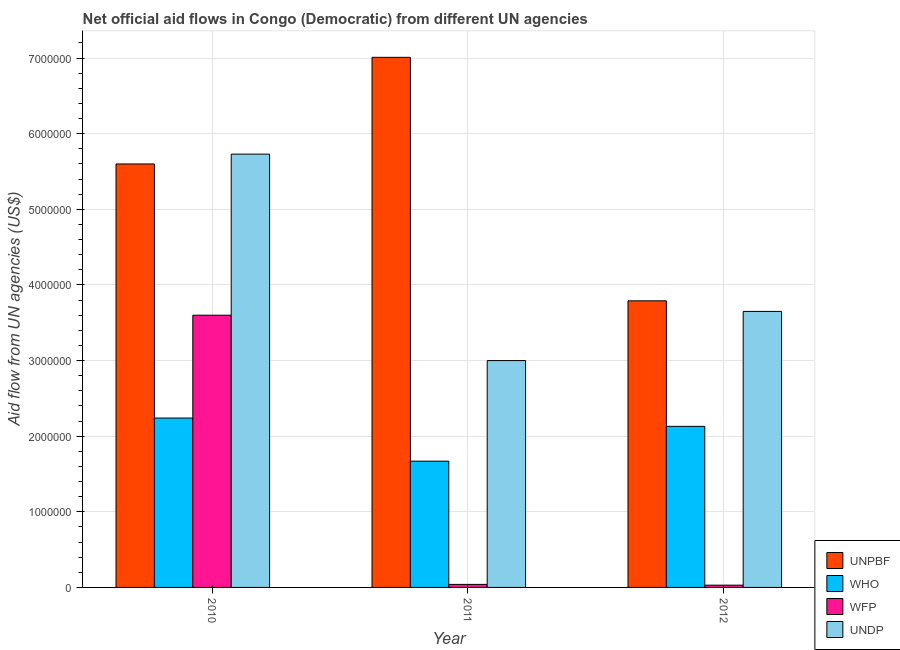How many different coloured bars are there?
Ensure brevity in your answer.  4. How many groups of bars are there?
Your response must be concise. 3. Are the number of bars per tick equal to the number of legend labels?
Keep it short and to the point. Yes. Are the number of bars on each tick of the X-axis equal?
Give a very brief answer. Yes. How many bars are there on the 2nd tick from the right?
Make the answer very short. 4. In how many cases, is the number of bars for a given year not equal to the number of legend labels?
Provide a succinct answer. 0. What is the amount of aid given by undp in 2011?
Ensure brevity in your answer.  3.00e+06. Across all years, what is the maximum amount of aid given by who?
Provide a succinct answer. 2.24e+06. Across all years, what is the minimum amount of aid given by undp?
Provide a succinct answer. 3.00e+06. In which year was the amount of aid given by who maximum?
Your answer should be compact. 2010. What is the total amount of aid given by wfp in the graph?
Give a very brief answer. 3.67e+06. What is the difference between the amount of aid given by unpbf in 2010 and that in 2012?
Give a very brief answer. 1.81e+06. What is the difference between the amount of aid given by unpbf in 2010 and the amount of aid given by wfp in 2011?
Provide a succinct answer. -1.41e+06. What is the average amount of aid given by unpbf per year?
Give a very brief answer. 5.47e+06. In the year 2012, what is the difference between the amount of aid given by who and amount of aid given by unpbf?
Your answer should be compact. 0. What is the ratio of the amount of aid given by unpbf in 2010 to that in 2012?
Your answer should be very brief. 1.48. Is the amount of aid given by who in 2010 less than that in 2011?
Offer a terse response. No. Is the difference between the amount of aid given by undp in 2010 and 2011 greater than the difference between the amount of aid given by who in 2010 and 2011?
Offer a terse response. No. What is the difference between the highest and the second highest amount of aid given by undp?
Make the answer very short. 2.08e+06. What is the difference between the highest and the lowest amount of aid given by undp?
Your response must be concise. 2.73e+06. Is it the case that in every year, the sum of the amount of aid given by undp and amount of aid given by who is greater than the sum of amount of aid given by wfp and amount of aid given by unpbf?
Offer a very short reply. No. What does the 1st bar from the left in 2012 represents?
Provide a succinct answer. UNPBF. What does the 3rd bar from the right in 2011 represents?
Give a very brief answer. WHO. How many bars are there?
Ensure brevity in your answer.  12. Are all the bars in the graph horizontal?
Your answer should be compact. No. How many years are there in the graph?
Provide a succinct answer. 3. Does the graph contain grids?
Keep it short and to the point. Yes. How many legend labels are there?
Keep it short and to the point. 4. How are the legend labels stacked?
Provide a short and direct response. Vertical. What is the title of the graph?
Keep it short and to the point. Net official aid flows in Congo (Democratic) from different UN agencies. Does "Bird species" appear as one of the legend labels in the graph?
Your answer should be very brief. No. What is the label or title of the Y-axis?
Make the answer very short. Aid flow from UN agencies (US$). What is the Aid flow from UN agencies (US$) of UNPBF in 2010?
Your answer should be compact. 5.60e+06. What is the Aid flow from UN agencies (US$) in WHO in 2010?
Your answer should be compact. 2.24e+06. What is the Aid flow from UN agencies (US$) of WFP in 2010?
Your answer should be compact. 3.60e+06. What is the Aid flow from UN agencies (US$) of UNDP in 2010?
Provide a short and direct response. 5.73e+06. What is the Aid flow from UN agencies (US$) in UNPBF in 2011?
Your answer should be very brief. 7.01e+06. What is the Aid flow from UN agencies (US$) in WHO in 2011?
Make the answer very short. 1.67e+06. What is the Aid flow from UN agencies (US$) of WFP in 2011?
Ensure brevity in your answer.  4.00e+04. What is the Aid flow from UN agencies (US$) in UNPBF in 2012?
Provide a succinct answer. 3.79e+06. What is the Aid flow from UN agencies (US$) in WHO in 2012?
Offer a very short reply. 2.13e+06. What is the Aid flow from UN agencies (US$) of WFP in 2012?
Your answer should be compact. 3.00e+04. What is the Aid flow from UN agencies (US$) in UNDP in 2012?
Give a very brief answer. 3.65e+06. Across all years, what is the maximum Aid flow from UN agencies (US$) in UNPBF?
Keep it short and to the point. 7.01e+06. Across all years, what is the maximum Aid flow from UN agencies (US$) in WHO?
Give a very brief answer. 2.24e+06. Across all years, what is the maximum Aid flow from UN agencies (US$) of WFP?
Provide a short and direct response. 3.60e+06. Across all years, what is the maximum Aid flow from UN agencies (US$) in UNDP?
Your answer should be very brief. 5.73e+06. Across all years, what is the minimum Aid flow from UN agencies (US$) of UNPBF?
Offer a very short reply. 3.79e+06. Across all years, what is the minimum Aid flow from UN agencies (US$) in WHO?
Ensure brevity in your answer.  1.67e+06. Across all years, what is the minimum Aid flow from UN agencies (US$) in UNDP?
Offer a terse response. 3.00e+06. What is the total Aid flow from UN agencies (US$) in UNPBF in the graph?
Offer a terse response. 1.64e+07. What is the total Aid flow from UN agencies (US$) of WHO in the graph?
Keep it short and to the point. 6.04e+06. What is the total Aid flow from UN agencies (US$) in WFP in the graph?
Your response must be concise. 3.67e+06. What is the total Aid flow from UN agencies (US$) in UNDP in the graph?
Provide a short and direct response. 1.24e+07. What is the difference between the Aid flow from UN agencies (US$) in UNPBF in 2010 and that in 2011?
Your answer should be compact. -1.41e+06. What is the difference between the Aid flow from UN agencies (US$) of WHO in 2010 and that in 2011?
Make the answer very short. 5.70e+05. What is the difference between the Aid flow from UN agencies (US$) of WFP in 2010 and that in 2011?
Provide a succinct answer. 3.56e+06. What is the difference between the Aid flow from UN agencies (US$) of UNDP in 2010 and that in 2011?
Keep it short and to the point. 2.73e+06. What is the difference between the Aid flow from UN agencies (US$) of UNPBF in 2010 and that in 2012?
Offer a terse response. 1.81e+06. What is the difference between the Aid flow from UN agencies (US$) in WFP in 2010 and that in 2012?
Provide a succinct answer. 3.57e+06. What is the difference between the Aid flow from UN agencies (US$) in UNDP in 2010 and that in 2012?
Give a very brief answer. 2.08e+06. What is the difference between the Aid flow from UN agencies (US$) in UNPBF in 2011 and that in 2012?
Keep it short and to the point. 3.22e+06. What is the difference between the Aid flow from UN agencies (US$) of WHO in 2011 and that in 2012?
Your answer should be compact. -4.60e+05. What is the difference between the Aid flow from UN agencies (US$) in UNDP in 2011 and that in 2012?
Your answer should be compact. -6.50e+05. What is the difference between the Aid flow from UN agencies (US$) of UNPBF in 2010 and the Aid flow from UN agencies (US$) of WHO in 2011?
Provide a succinct answer. 3.93e+06. What is the difference between the Aid flow from UN agencies (US$) in UNPBF in 2010 and the Aid flow from UN agencies (US$) in WFP in 2011?
Provide a short and direct response. 5.56e+06. What is the difference between the Aid flow from UN agencies (US$) of UNPBF in 2010 and the Aid flow from UN agencies (US$) of UNDP in 2011?
Offer a terse response. 2.60e+06. What is the difference between the Aid flow from UN agencies (US$) in WHO in 2010 and the Aid flow from UN agencies (US$) in WFP in 2011?
Make the answer very short. 2.20e+06. What is the difference between the Aid flow from UN agencies (US$) of WHO in 2010 and the Aid flow from UN agencies (US$) of UNDP in 2011?
Your answer should be compact. -7.60e+05. What is the difference between the Aid flow from UN agencies (US$) of WFP in 2010 and the Aid flow from UN agencies (US$) of UNDP in 2011?
Your answer should be compact. 6.00e+05. What is the difference between the Aid flow from UN agencies (US$) of UNPBF in 2010 and the Aid flow from UN agencies (US$) of WHO in 2012?
Make the answer very short. 3.47e+06. What is the difference between the Aid flow from UN agencies (US$) of UNPBF in 2010 and the Aid flow from UN agencies (US$) of WFP in 2012?
Your response must be concise. 5.57e+06. What is the difference between the Aid flow from UN agencies (US$) in UNPBF in 2010 and the Aid flow from UN agencies (US$) in UNDP in 2012?
Provide a succinct answer. 1.95e+06. What is the difference between the Aid flow from UN agencies (US$) in WHO in 2010 and the Aid flow from UN agencies (US$) in WFP in 2012?
Give a very brief answer. 2.21e+06. What is the difference between the Aid flow from UN agencies (US$) in WHO in 2010 and the Aid flow from UN agencies (US$) in UNDP in 2012?
Offer a very short reply. -1.41e+06. What is the difference between the Aid flow from UN agencies (US$) of WFP in 2010 and the Aid flow from UN agencies (US$) of UNDP in 2012?
Your answer should be very brief. -5.00e+04. What is the difference between the Aid flow from UN agencies (US$) in UNPBF in 2011 and the Aid flow from UN agencies (US$) in WHO in 2012?
Provide a short and direct response. 4.88e+06. What is the difference between the Aid flow from UN agencies (US$) in UNPBF in 2011 and the Aid flow from UN agencies (US$) in WFP in 2012?
Your answer should be compact. 6.98e+06. What is the difference between the Aid flow from UN agencies (US$) of UNPBF in 2011 and the Aid flow from UN agencies (US$) of UNDP in 2012?
Provide a short and direct response. 3.36e+06. What is the difference between the Aid flow from UN agencies (US$) in WHO in 2011 and the Aid flow from UN agencies (US$) in WFP in 2012?
Ensure brevity in your answer.  1.64e+06. What is the difference between the Aid flow from UN agencies (US$) in WHO in 2011 and the Aid flow from UN agencies (US$) in UNDP in 2012?
Your answer should be compact. -1.98e+06. What is the difference between the Aid flow from UN agencies (US$) in WFP in 2011 and the Aid flow from UN agencies (US$) in UNDP in 2012?
Your answer should be compact. -3.61e+06. What is the average Aid flow from UN agencies (US$) of UNPBF per year?
Provide a short and direct response. 5.47e+06. What is the average Aid flow from UN agencies (US$) of WHO per year?
Your answer should be compact. 2.01e+06. What is the average Aid flow from UN agencies (US$) of WFP per year?
Offer a very short reply. 1.22e+06. What is the average Aid flow from UN agencies (US$) of UNDP per year?
Your response must be concise. 4.13e+06. In the year 2010, what is the difference between the Aid flow from UN agencies (US$) of UNPBF and Aid flow from UN agencies (US$) of WHO?
Keep it short and to the point. 3.36e+06. In the year 2010, what is the difference between the Aid flow from UN agencies (US$) of UNPBF and Aid flow from UN agencies (US$) of WFP?
Ensure brevity in your answer.  2.00e+06. In the year 2010, what is the difference between the Aid flow from UN agencies (US$) of WHO and Aid flow from UN agencies (US$) of WFP?
Provide a succinct answer. -1.36e+06. In the year 2010, what is the difference between the Aid flow from UN agencies (US$) of WHO and Aid flow from UN agencies (US$) of UNDP?
Offer a very short reply. -3.49e+06. In the year 2010, what is the difference between the Aid flow from UN agencies (US$) of WFP and Aid flow from UN agencies (US$) of UNDP?
Offer a very short reply. -2.13e+06. In the year 2011, what is the difference between the Aid flow from UN agencies (US$) of UNPBF and Aid flow from UN agencies (US$) of WHO?
Your response must be concise. 5.34e+06. In the year 2011, what is the difference between the Aid flow from UN agencies (US$) in UNPBF and Aid flow from UN agencies (US$) in WFP?
Your answer should be very brief. 6.97e+06. In the year 2011, what is the difference between the Aid flow from UN agencies (US$) in UNPBF and Aid flow from UN agencies (US$) in UNDP?
Your answer should be very brief. 4.01e+06. In the year 2011, what is the difference between the Aid flow from UN agencies (US$) in WHO and Aid flow from UN agencies (US$) in WFP?
Keep it short and to the point. 1.63e+06. In the year 2011, what is the difference between the Aid flow from UN agencies (US$) in WHO and Aid flow from UN agencies (US$) in UNDP?
Offer a very short reply. -1.33e+06. In the year 2011, what is the difference between the Aid flow from UN agencies (US$) of WFP and Aid flow from UN agencies (US$) of UNDP?
Your answer should be very brief. -2.96e+06. In the year 2012, what is the difference between the Aid flow from UN agencies (US$) of UNPBF and Aid flow from UN agencies (US$) of WHO?
Provide a succinct answer. 1.66e+06. In the year 2012, what is the difference between the Aid flow from UN agencies (US$) in UNPBF and Aid flow from UN agencies (US$) in WFP?
Your answer should be compact. 3.76e+06. In the year 2012, what is the difference between the Aid flow from UN agencies (US$) in WHO and Aid flow from UN agencies (US$) in WFP?
Make the answer very short. 2.10e+06. In the year 2012, what is the difference between the Aid flow from UN agencies (US$) in WHO and Aid flow from UN agencies (US$) in UNDP?
Give a very brief answer. -1.52e+06. In the year 2012, what is the difference between the Aid flow from UN agencies (US$) of WFP and Aid flow from UN agencies (US$) of UNDP?
Give a very brief answer. -3.62e+06. What is the ratio of the Aid flow from UN agencies (US$) in UNPBF in 2010 to that in 2011?
Make the answer very short. 0.8. What is the ratio of the Aid flow from UN agencies (US$) in WHO in 2010 to that in 2011?
Make the answer very short. 1.34. What is the ratio of the Aid flow from UN agencies (US$) of UNDP in 2010 to that in 2011?
Offer a very short reply. 1.91. What is the ratio of the Aid flow from UN agencies (US$) of UNPBF in 2010 to that in 2012?
Offer a terse response. 1.48. What is the ratio of the Aid flow from UN agencies (US$) in WHO in 2010 to that in 2012?
Keep it short and to the point. 1.05. What is the ratio of the Aid flow from UN agencies (US$) of WFP in 2010 to that in 2012?
Ensure brevity in your answer.  120. What is the ratio of the Aid flow from UN agencies (US$) in UNDP in 2010 to that in 2012?
Offer a terse response. 1.57. What is the ratio of the Aid flow from UN agencies (US$) of UNPBF in 2011 to that in 2012?
Keep it short and to the point. 1.85. What is the ratio of the Aid flow from UN agencies (US$) of WHO in 2011 to that in 2012?
Your response must be concise. 0.78. What is the ratio of the Aid flow from UN agencies (US$) of WFP in 2011 to that in 2012?
Your response must be concise. 1.33. What is the ratio of the Aid flow from UN agencies (US$) of UNDP in 2011 to that in 2012?
Provide a short and direct response. 0.82. What is the difference between the highest and the second highest Aid flow from UN agencies (US$) of UNPBF?
Your answer should be very brief. 1.41e+06. What is the difference between the highest and the second highest Aid flow from UN agencies (US$) in WFP?
Provide a succinct answer. 3.56e+06. What is the difference between the highest and the second highest Aid flow from UN agencies (US$) in UNDP?
Your response must be concise. 2.08e+06. What is the difference between the highest and the lowest Aid flow from UN agencies (US$) of UNPBF?
Offer a terse response. 3.22e+06. What is the difference between the highest and the lowest Aid flow from UN agencies (US$) of WHO?
Your answer should be compact. 5.70e+05. What is the difference between the highest and the lowest Aid flow from UN agencies (US$) in WFP?
Ensure brevity in your answer.  3.57e+06. What is the difference between the highest and the lowest Aid flow from UN agencies (US$) in UNDP?
Your answer should be very brief. 2.73e+06. 